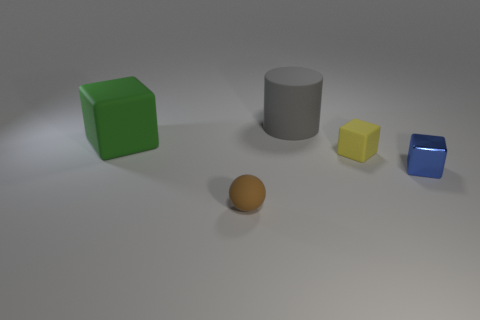Is there anything else that has the same material as the gray cylinder?
Ensure brevity in your answer.  Yes. How many rubber objects are either large green things or purple balls?
Ensure brevity in your answer.  1. There is a matte block that is to the right of the big green thing; what size is it?
Provide a succinct answer. Small. What is the size of the green object that is the same material as the large gray thing?
Your answer should be very brief. Large. What number of big matte blocks are the same color as the tiny matte cube?
Provide a short and direct response. 0. Are there any tiny cyan cubes?
Your answer should be very brief. No. There is a tiny brown matte object; does it have the same shape as the object that is to the left of the brown object?
Keep it short and to the point. No. The object that is on the right side of the rubber block that is in front of the matte block on the left side of the yellow cube is what color?
Your answer should be very brief. Blue. Are there any green things in front of the brown matte object?
Ensure brevity in your answer.  No. Is there a thing that has the same material as the sphere?
Your answer should be very brief. Yes. 